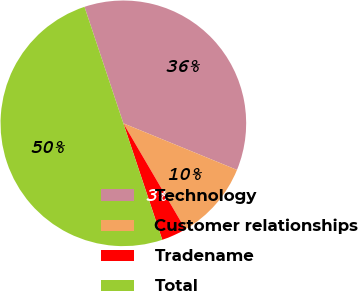Convert chart. <chart><loc_0><loc_0><loc_500><loc_500><pie_chart><fcel>Technology<fcel>Customer relationships<fcel>Tradename<fcel>Total<nl><fcel>36.32%<fcel>10.38%<fcel>3.3%<fcel>50.0%<nl></chart> 